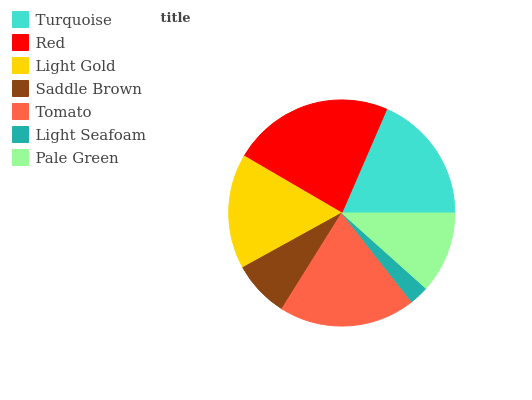Is Light Seafoam the minimum?
Answer yes or no. Yes. Is Red the maximum?
Answer yes or no. Yes. Is Light Gold the minimum?
Answer yes or no. No. Is Light Gold the maximum?
Answer yes or no. No. Is Red greater than Light Gold?
Answer yes or no. Yes. Is Light Gold less than Red?
Answer yes or no. Yes. Is Light Gold greater than Red?
Answer yes or no. No. Is Red less than Light Gold?
Answer yes or no. No. Is Light Gold the high median?
Answer yes or no. Yes. Is Light Gold the low median?
Answer yes or no. Yes. Is Turquoise the high median?
Answer yes or no. No. Is Saddle Brown the low median?
Answer yes or no. No. 